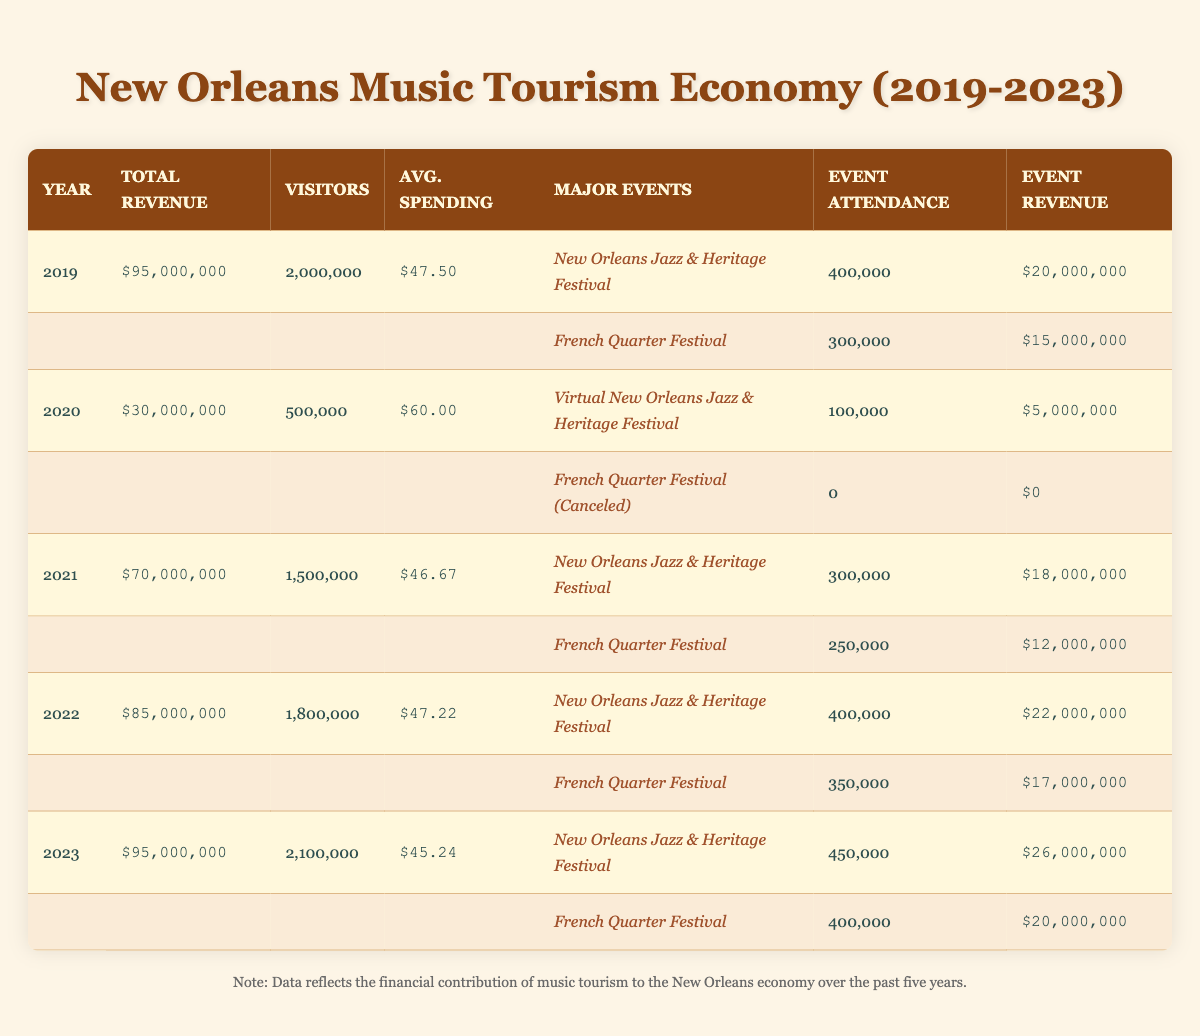What was the total music tourism revenue in 2021? The table lists the total music tourism revenue for each year. For 2021, the corresponding value is located in the "Total Revenue" column for that year, which is $70,000,000.
Answer: $70,000,000 How many visitors came to New Orleans for music tourism in 2022? The number of visitors for music tourism is provided in the table under the "Visitors" column for the year 2022. That number is 1,800,000.
Answer: 1,800,000 What is the average spending per visitor in 2020 compared to 2021? The average spending per visitor for 2020 is $60.00 and for 2021 is $46.67. To compare, we observe that spending in 2020 was higher than in 2021.
Answer: 2020 was higher Did the attendance for the French Quarter Festival increase from 2019 to 2023? From the table, attendance for the French Quarter Festival in 2019 is 300,000, and in 2023 it increased to 400,000. Therefore, attendance increased over these years.
Answer: Yes What was the total revenue generated by the New Orleans Jazz & Heritage Festival from 2019 to 2023? To find the total revenue generated by the New Orleans Jazz & Heritage Festival, we sum the individual revenues for each year as listed: 2019 ($20,000,000) + 2020 ($5,000,000) + 2021 ($18,000,000) + 2022 ($22,000,000) + 2023 ($26,000,000) = $91,000,000.
Answer: $91,000,000 In which year did music tourism generate the lowest total revenue, and how much was it? By comparing the total revenues from all the years listed, 2020 has the lowest total revenue at $30,000,000.
Answer: 2020, $30,000,000 What is the difference in average spending per visitor between 2019 and 2023? The average spending per visitor in 2019 is $47.50 and in 2023 is $45.24. Calculating the difference: $47.50 - $45.24 results in $2.26.
Answer: $2.26 How did the attendance of the New Orleans Jazz & Heritage Festival change from 2019 to 2023? Attendance for the New Orleans Jazz & Heritage Festival in 2019 is 400,000 and in 2023 it increased to 450,000. Thus, attendance increased by 50,000 over the years.
Answer: Increased by 50,000 